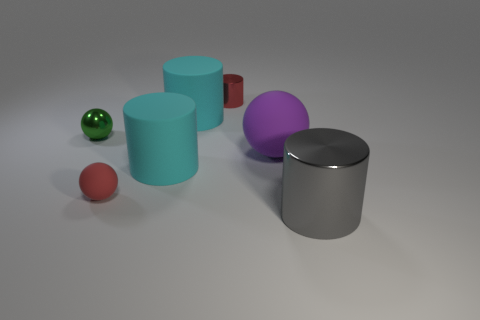Are the large gray object and the large purple sphere made of the same material?
Offer a very short reply. No. Is the number of metal things behind the small green sphere greater than the number of tiny brown metallic cylinders?
Keep it short and to the point. Yes. How many objects are tiny brown objects or cyan cylinders that are behind the green metallic ball?
Offer a terse response. 1. Is the number of gray objects that are in front of the tiny red rubber ball greater than the number of spheres to the right of the big purple sphere?
Give a very brief answer. Yes. What is the material of the big cyan cylinder in front of the big cyan matte cylinder that is right of the cyan thing in front of the tiny green object?
Offer a very short reply. Rubber. What shape is the other small object that is made of the same material as the purple object?
Provide a succinct answer. Sphere. There is a tiny shiny thing that is behind the tiny green sphere; are there any red things on the left side of it?
Offer a terse response. Yes. What is the size of the red rubber ball?
Give a very brief answer. Small. What number of objects are either small green metallic spheres or purple rubber cylinders?
Your answer should be compact. 1. Are the small sphere in front of the purple matte object and the cylinder that is to the right of the small cylinder made of the same material?
Give a very brief answer. No. 